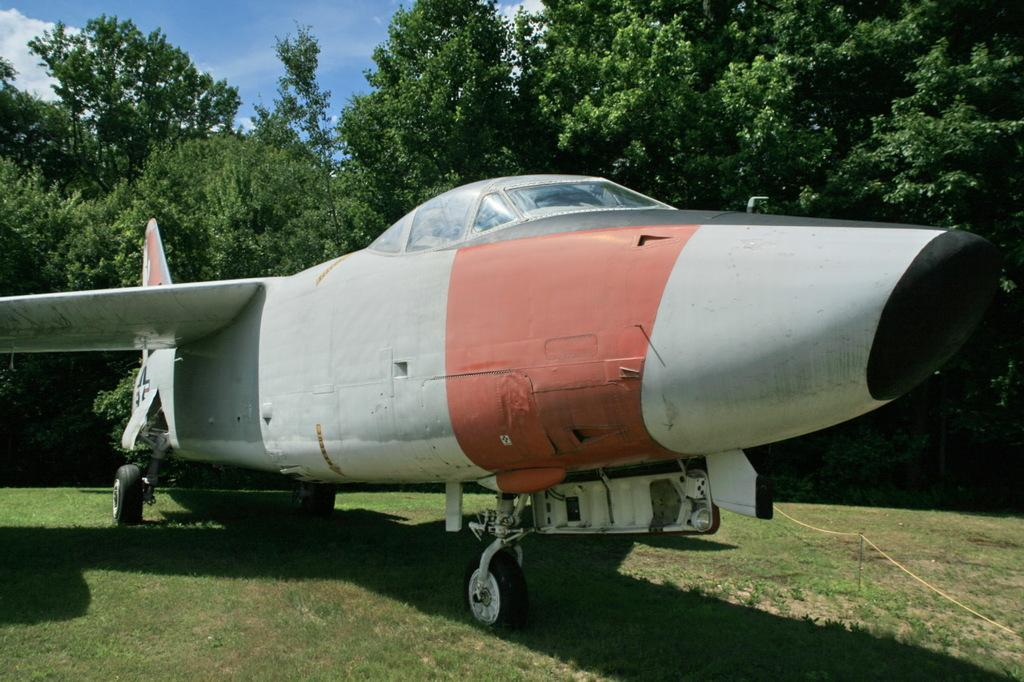What is the main subject of the image? The main subject of the image is an airplane on the ground. What type of vegetation can be seen in the image? There are trees and grass in the image. What object is present in the image that might be used for tying or securing? There is a rope in the image. What can be seen in the background of the image? The sky with clouds is visible in the background of the image. How many geese are sitting on the chairs in the image? There are no geese or chairs present in the image. What type of operation is being performed on the airplane in the image? There is no operation being performed on the airplane in the image; it is simply on the ground. 